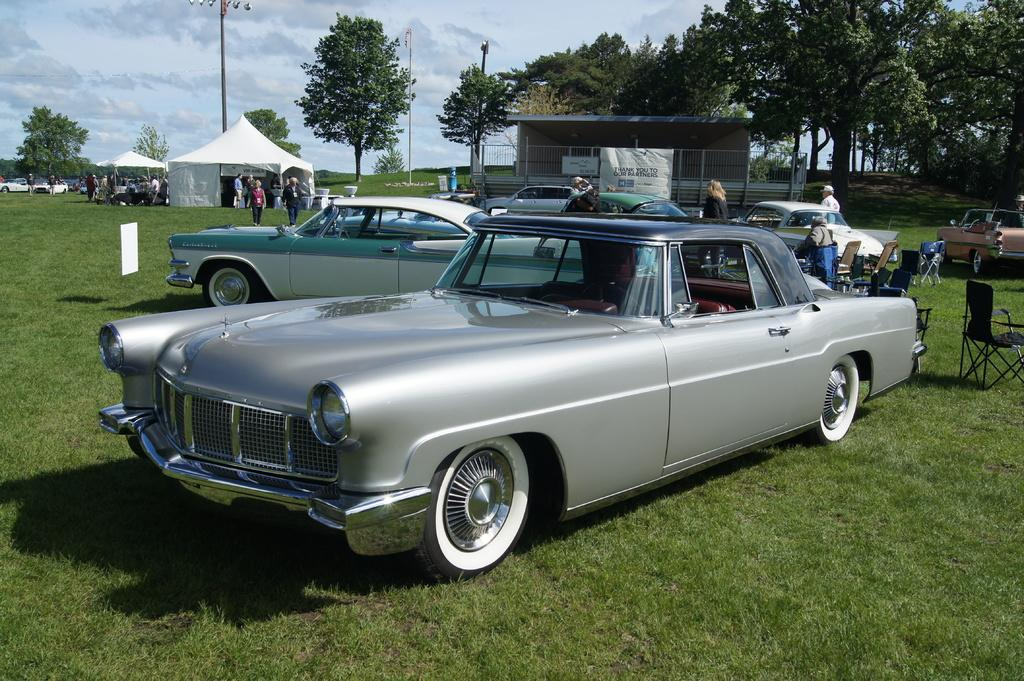What type of vehicles can be seen in the image? There are cars in the image. Can you describe the appearance of the cars? The cars are in different colors. What can be seen in the background of the image? There are white tents, a shade, trees, and people in the background. What type of seating is available in the image? There are chairs in the image. How would you describe the color of the sky in the image? The sky is blue and white in color. How many tomatoes are on the chairs in the image? There are no tomatoes present in the image; it features cars, white tents, a shade, trees, people, chairs, and a blue and white sky. What type of show is being performed in the image? There is no show being performed in the image; it is a scene with cars, white tents, a shade, trees, people, chairs, and a blue and white sky. 